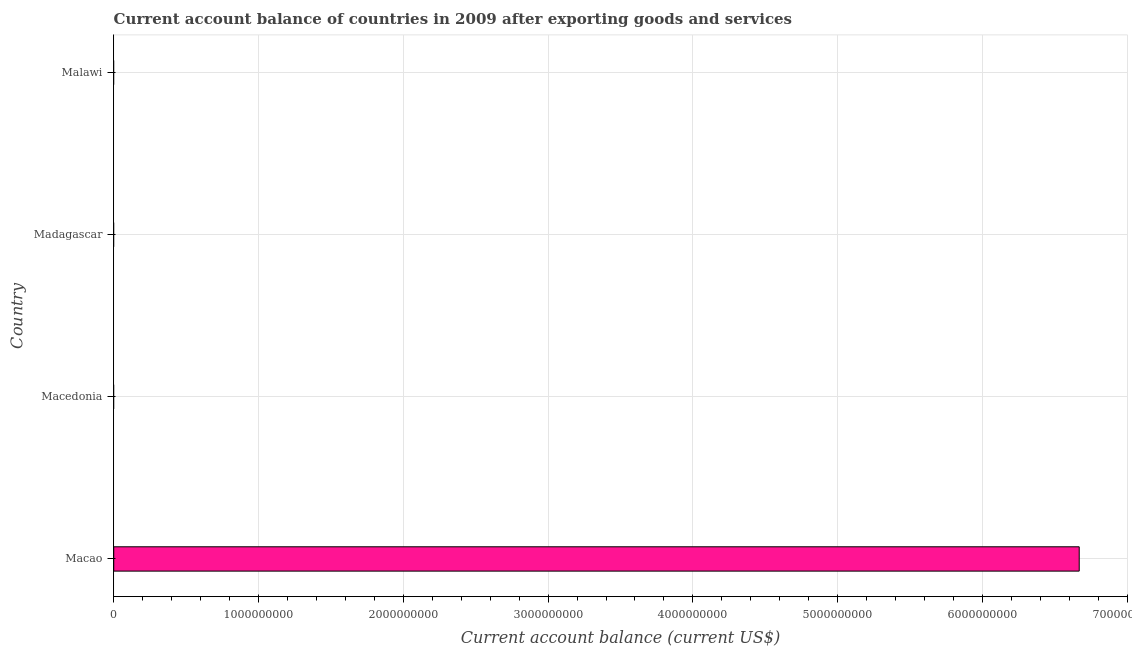Does the graph contain grids?
Provide a succinct answer. Yes. What is the title of the graph?
Offer a terse response. Current account balance of countries in 2009 after exporting goods and services. What is the label or title of the X-axis?
Your response must be concise. Current account balance (current US$). What is the current account balance in Macao?
Provide a succinct answer. 6.67e+09. Across all countries, what is the maximum current account balance?
Ensure brevity in your answer.  6.67e+09. Across all countries, what is the minimum current account balance?
Ensure brevity in your answer.  0. In which country was the current account balance maximum?
Your answer should be very brief. Macao. What is the sum of the current account balance?
Provide a succinct answer. 6.67e+09. What is the average current account balance per country?
Provide a short and direct response. 1.67e+09. In how many countries, is the current account balance greater than 2200000000 US$?
Keep it short and to the point. 1. What is the difference between the highest and the lowest current account balance?
Give a very brief answer. 6.67e+09. In how many countries, is the current account balance greater than the average current account balance taken over all countries?
Make the answer very short. 1. Are all the bars in the graph horizontal?
Your response must be concise. Yes. How many countries are there in the graph?
Your response must be concise. 4. What is the difference between two consecutive major ticks on the X-axis?
Provide a succinct answer. 1.00e+09. Are the values on the major ticks of X-axis written in scientific E-notation?
Provide a succinct answer. No. What is the Current account balance (current US$) of Macao?
Ensure brevity in your answer.  6.67e+09. What is the Current account balance (current US$) of Malawi?
Ensure brevity in your answer.  0. 